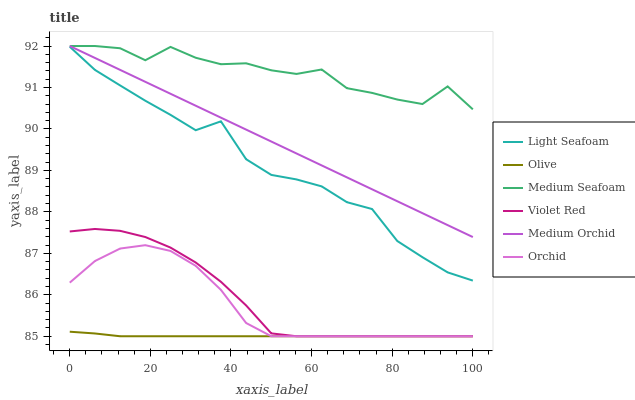Does Medium Orchid have the minimum area under the curve?
Answer yes or no. No. Does Medium Orchid have the maximum area under the curve?
Answer yes or no. No. Is Olive the smoothest?
Answer yes or no. No. Is Olive the roughest?
Answer yes or no. No. Does Medium Orchid have the lowest value?
Answer yes or no. No. Does Olive have the highest value?
Answer yes or no. No. Is Orchid less than Light Seafoam?
Answer yes or no. Yes. Is Light Seafoam greater than Olive?
Answer yes or no. Yes. Does Orchid intersect Light Seafoam?
Answer yes or no. No. 